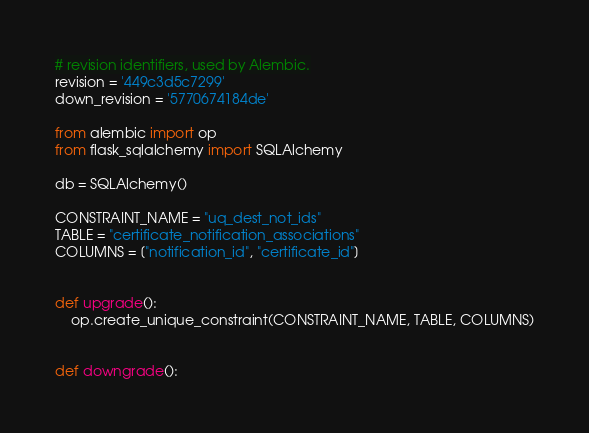Convert code to text. <code><loc_0><loc_0><loc_500><loc_500><_Python_>
# revision identifiers, used by Alembic.
revision = '449c3d5c7299'
down_revision = '5770674184de'

from alembic import op
from flask_sqlalchemy import SQLAlchemy

db = SQLAlchemy()

CONSTRAINT_NAME = "uq_dest_not_ids"
TABLE = "certificate_notification_associations"
COLUMNS = ["notification_id", "certificate_id"]


def upgrade():
    op.create_unique_constraint(CONSTRAINT_NAME, TABLE, COLUMNS)


def downgrade():</code> 